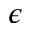Convert formula to latex. <formula><loc_0><loc_0><loc_500><loc_500>\epsilon</formula> 